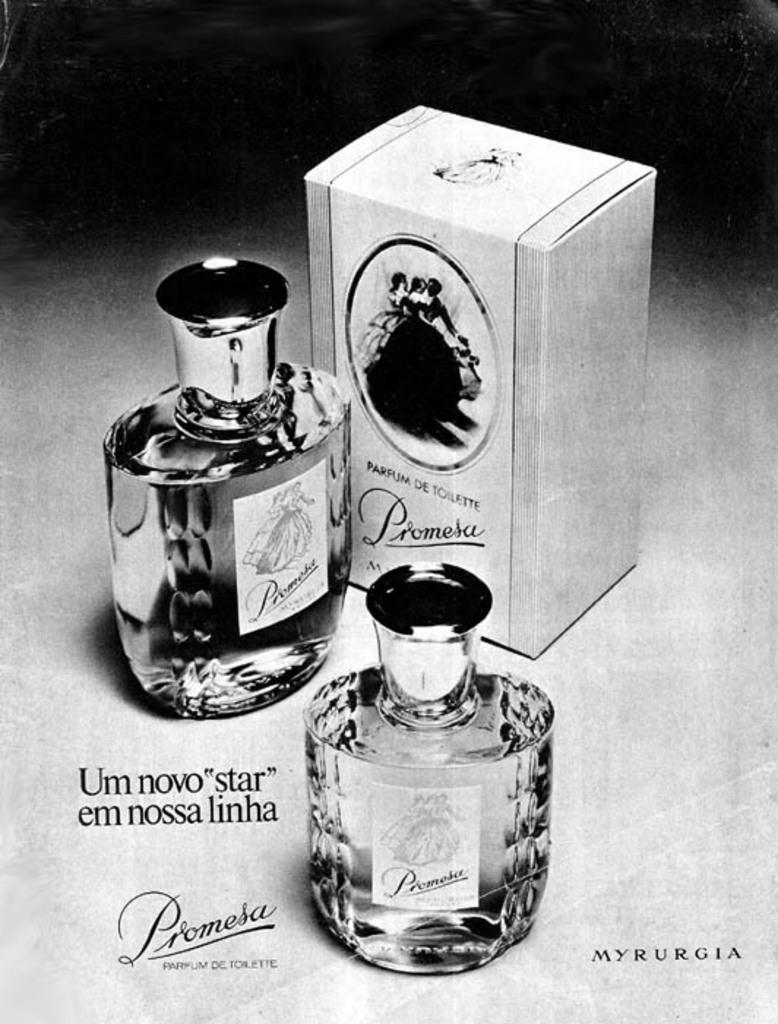<image>
Present a compact description of the photo's key features. Two bottles of perfume next to a box that says Promesa. 